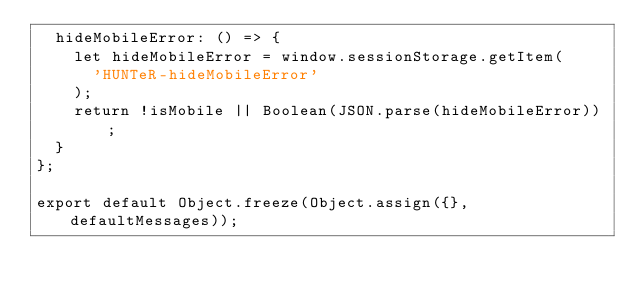Convert code to text. <code><loc_0><loc_0><loc_500><loc_500><_JavaScript_>  hideMobileError: () => {
    let hideMobileError = window.sessionStorage.getItem(
      'HUNTeR-hideMobileError'
    );
    return !isMobile || Boolean(JSON.parse(hideMobileError));
  }
};

export default Object.freeze(Object.assign({}, defaultMessages));
</code> 